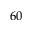Convert formula to latex. <formula><loc_0><loc_0><loc_500><loc_500>6 0</formula> 